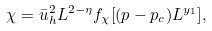<formula> <loc_0><loc_0><loc_500><loc_500>\chi = \bar { u } _ { h } ^ { 2 } L ^ { 2 - \eta } f _ { \chi } [ ( p - p _ { c } ) L ^ { y _ { 1 } } ] ,</formula> 